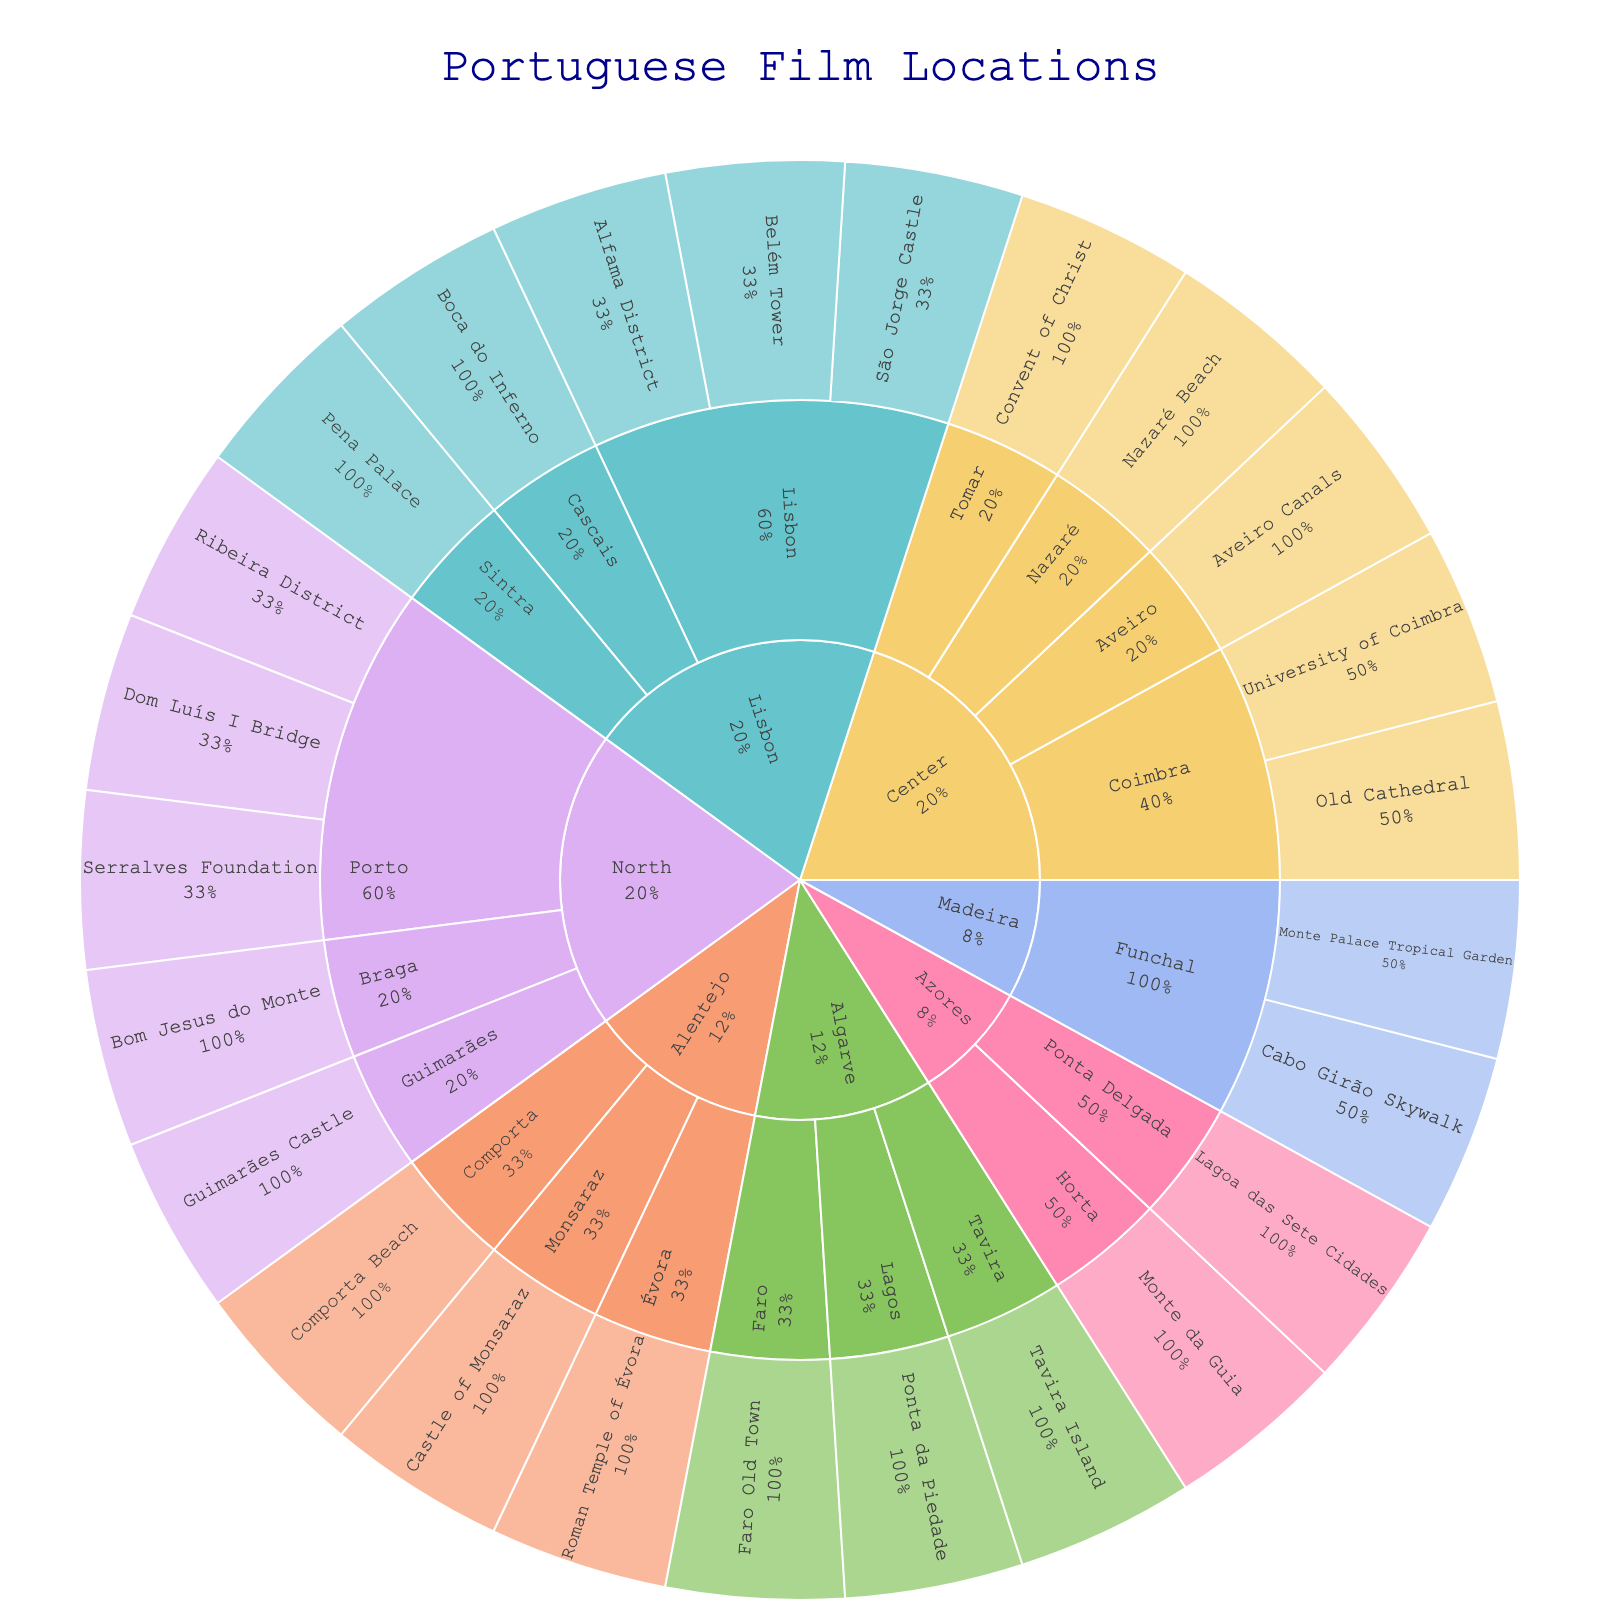What is the title of the sunburst plot? The title of the plot is centered at the top and displayed prominently in a larger font size. The text "Portuguese Film Locations" is clearly visible.
Answer: Portuguese Film Locations Which regions in Portugal are featured in the plot? The regions are represented in the outermost segments of the plot with distinct colors and labeled appropriately. The visible regions include North, Center, Lisbon, Alentejo, Algarve, Madeira, and Azores.
Answer: North, Center, Lisbon, Alentejo, Algarve, Madeira, Azores How many locations in Porto are shown on the plot? Each city within a region is represented by a segment, and each location within a city is further divided into smaller segments. To find the number of locations in Porto, we count the segments displayed under the Porto section within the North region.
Answer: 3 Which city has the largest number of film locations in the Lisbon region? By observing the number of segments within each city in the Lisbon region, we can find the city with the most locations. Lisbon has the highest number as it is split into the most segments among the cities listed under Lisbon region.
Answer: Lisbon Which region has more locations, Algarve or Madeira? To compare the number of locations in each region, we count the segments under their respective zones. Algarve has three locations (Faro, Lagos, Tavira), while Madeira has two (Funchal, Monte).
Answer: Algarve What percentage of the locations in the North region does Porto occupy? To determine the percentage, count the number of locations in Porto and compare it to the total number of locations in the North region. Porto has 3 locations out of the total 5, thus the percentage is (3/5)*100.
Answer: 60% Which landmark in the Azores region is located in Ponta Delgada? Each city segment is divided into smaller segments representing individual landmarks. Ponta Delgada within Azores is clearly shown with Lagoa das Sete Cidades as one of its locations.
Answer: Lagoa das Sete Cidades Does Sintra have more film locations than Cascais in the Lisbon region? By comparing the number of segments under Sintra and Cascais cities within the Lisbon region, we see that Sintra has one segment while Cascais also has one.
Answer: No Identify which location in the Center region is associated with Tomar. Look under the Center region’s segments and find Tomar. The location under it is divided into further segments representing specific landmarks, showcasing Convent of Christ.
Answer: Convent of Christ What are the specific landmarks listed under Évora in the Alentejo region? Under the Alentejo region, find the Évora segment and read the inner segments which list the specific landmarks. Évora features the Roman Temple of Évora.
Answer: Roman Temple of Évora 